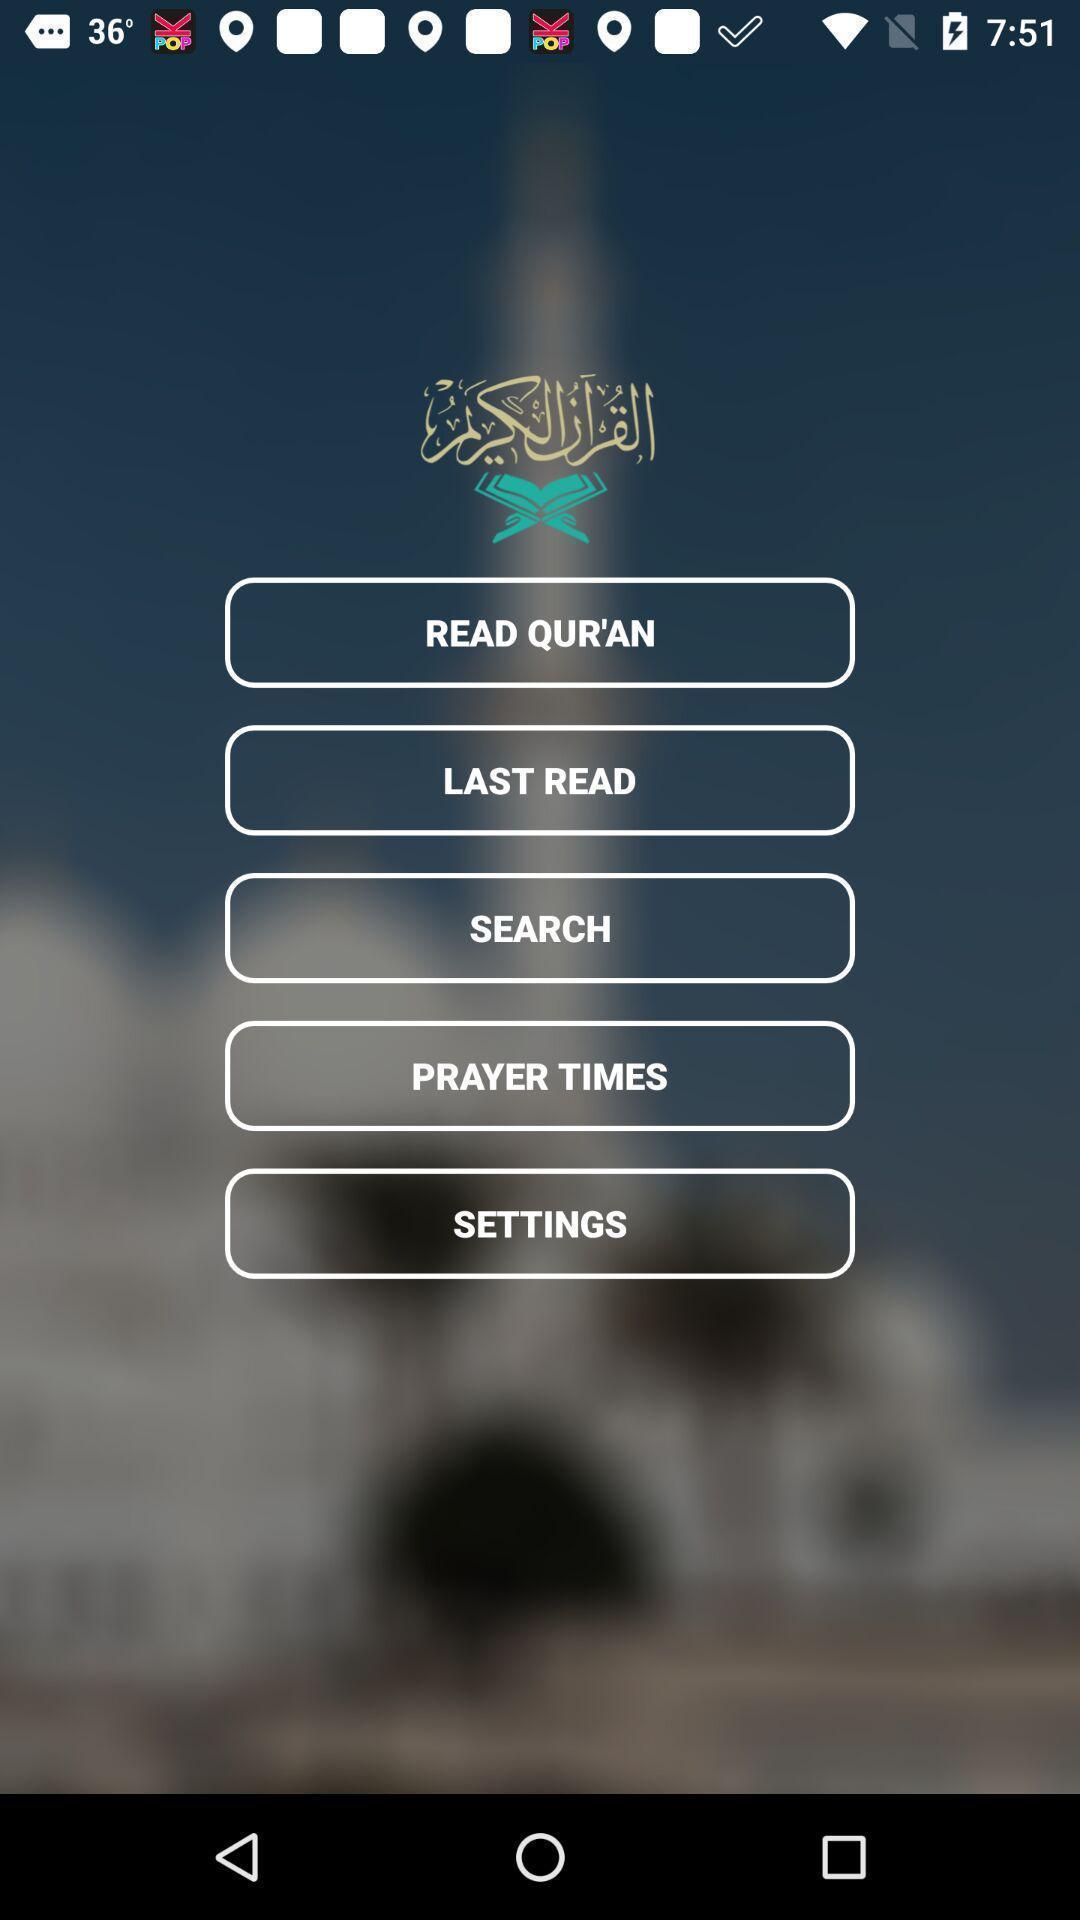Provide a detailed account of this screenshot. Welcome page of a devotional app. 